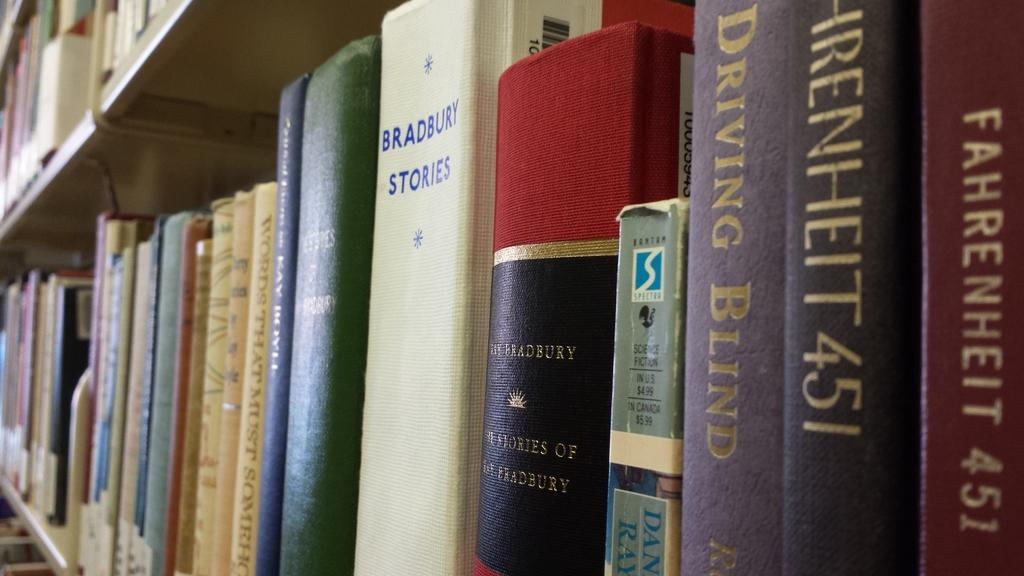<image>
Share a concise interpretation of the image provided. Several books are lined neatly on a shelf, including Fahrenheit 451. 